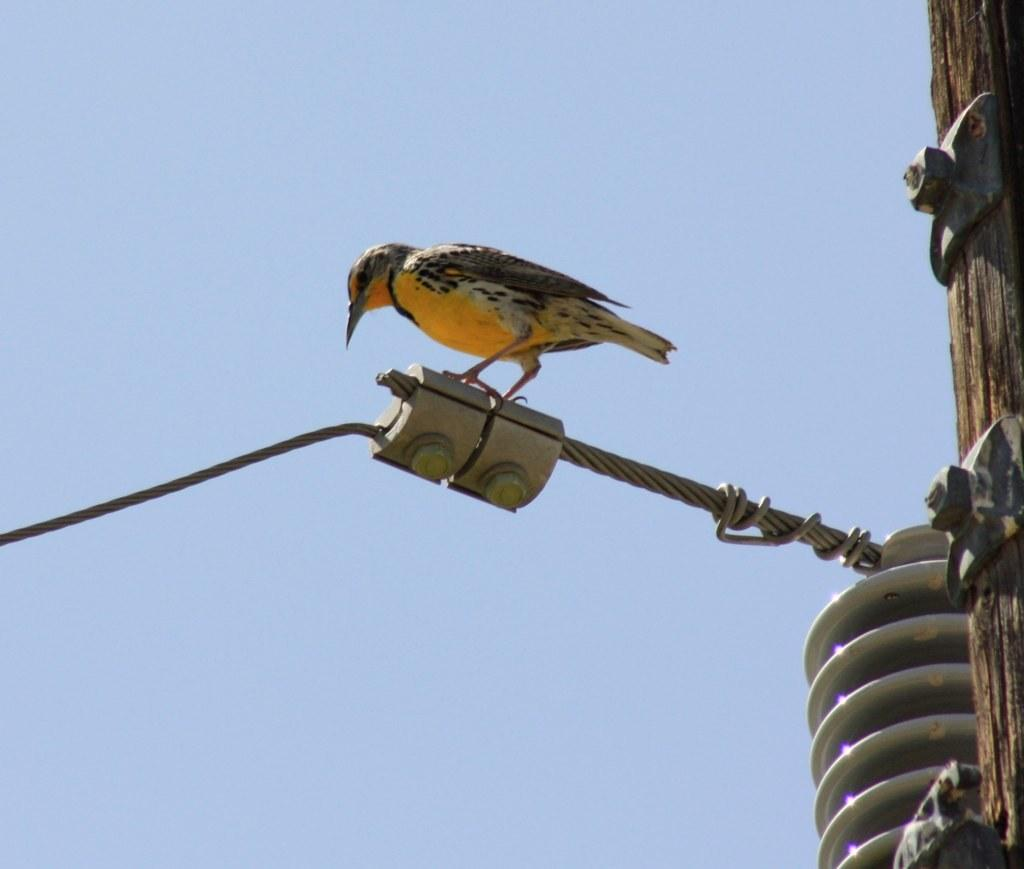What type of animal is present in the image? There is a bird in the image. Can you describe the color of the bird? The bird is brown and white in color. What is the bird standing on in the image? The bird is standing on a pole. What is the color of the sky in the image? The sky is blue in the image. Can you observe any fact at the seashore in the image? There is no mention of a seashore or any facts in the image. 